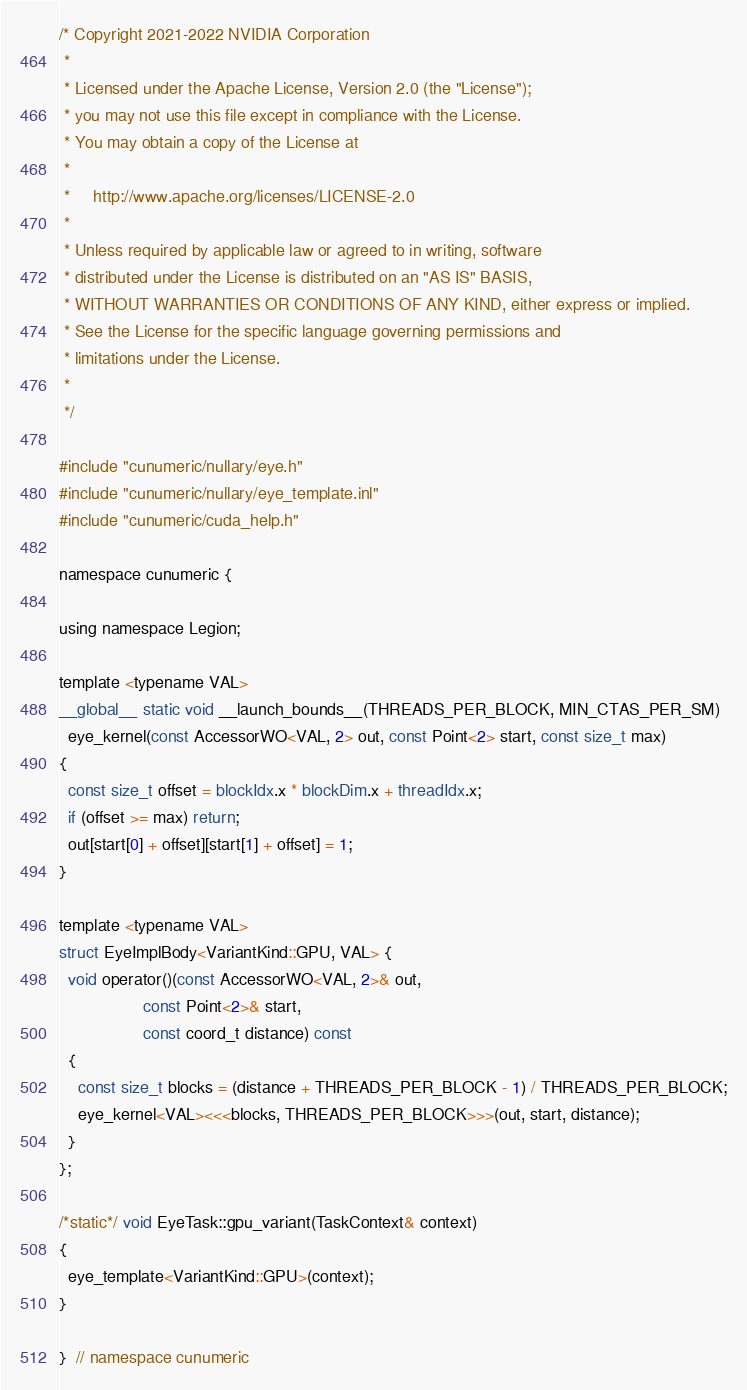<code> <loc_0><loc_0><loc_500><loc_500><_Cuda_>/* Copyright 2021-2022 NVIDIA Corporation
 *
 * Licensed under the Apache License, Version 2.0 (the "License");
 * you may not use this file except in compliance with the License.
 * You may obtain a copy of the License at
 *
 *     http://www.apache.org/licenses/LICENSE-2.0
 *
 * Unless required by applicable law or agreed to in writing, software
 * distributed under the License is distributed on an "AS IS" BASIS,
 * WITHOUT WARRANTIES OR CONDITIONS OF ANY KIND, either express or implied.
 * See the License for the specific language governing permissions and
 * limitations under the License.
 *
 */

#include "cunumeric/nullary/eye.h"
#include "cunumeric/nullary/eye_template.inl"
#include "cunumeric/cuda_help.h"

namespace cunumeric {

using namespace Legion;

template <typename VAL>
__global__ static void __launch_bounds__(THREADS_PER_BLOCK, MIN_CTAS_PER_SM)
  eye_kernel(const AccessorWO<VAL, 2> out, const Point<2> start, const size_t max)
{
  const size_t offset = blockIdx.x * blockDim.x + threadIdx.x;
  if (offset >= max) return;
  out[start[0] + offset][start[1] + offset] = 1;
}

template <typename VAL>
struct EyeImplBody<VariantKind::GPU, VAL> {
  void operator()(const AccessorWO<VAL, 2>& out,
                  const Point<2>& start,
                  const coord_t distance) const
  {
    const size_t blocks = (distance + THREADS_PER_BLOCK - 1) / THREADS_PER_BLOCK;
    eye_kernel<VAL><<<blocks, THREADS_PER_BLOCK>>>(out, start, distance);
  }
};

/*static*/ void EyeTask::gpu_variant(TaskContext& context)
{
  eye_template<VariantKind::GPU>(context);
}

}  // namespace cunumeric
</code> 